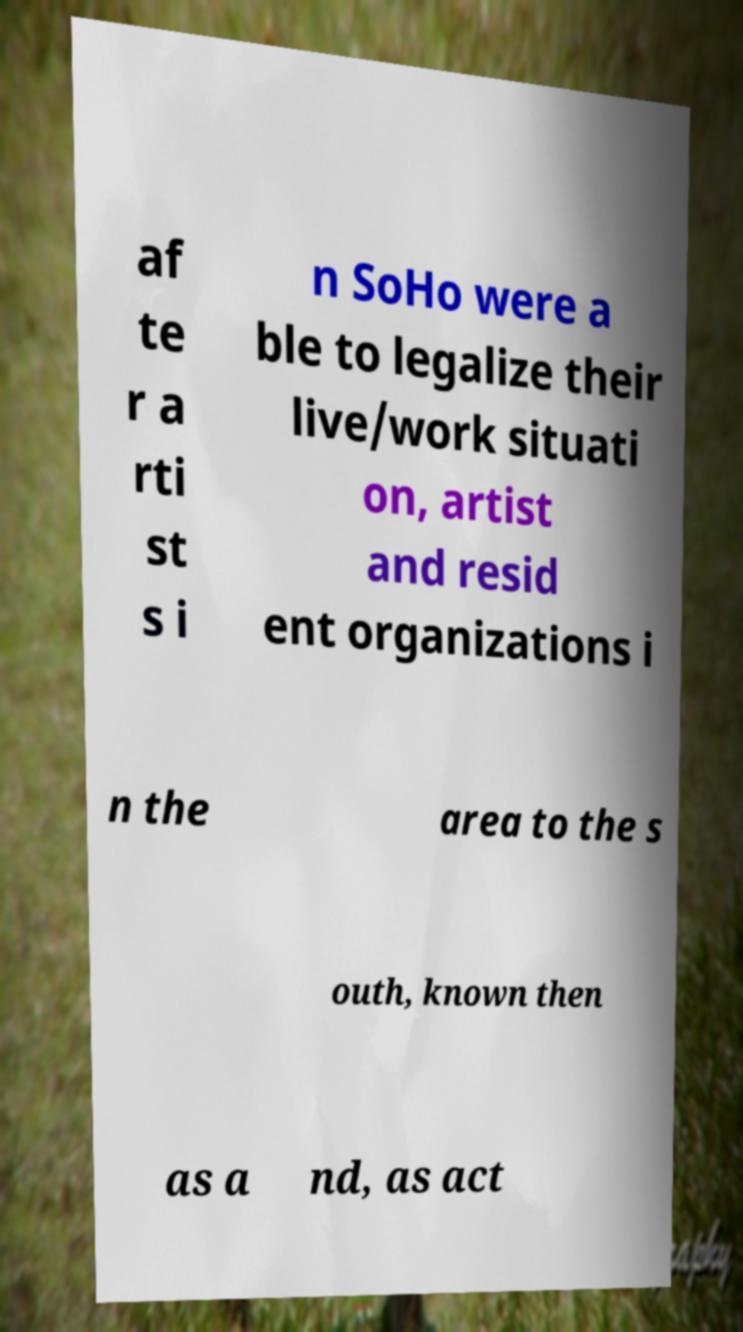Please identify and transcribe the text found in this image. af te r a rti st s i n SoHo were a ble to legalize their live/work situati on, artist and resid ent organizations i n the area to the s outh, known then as a nd, as act 